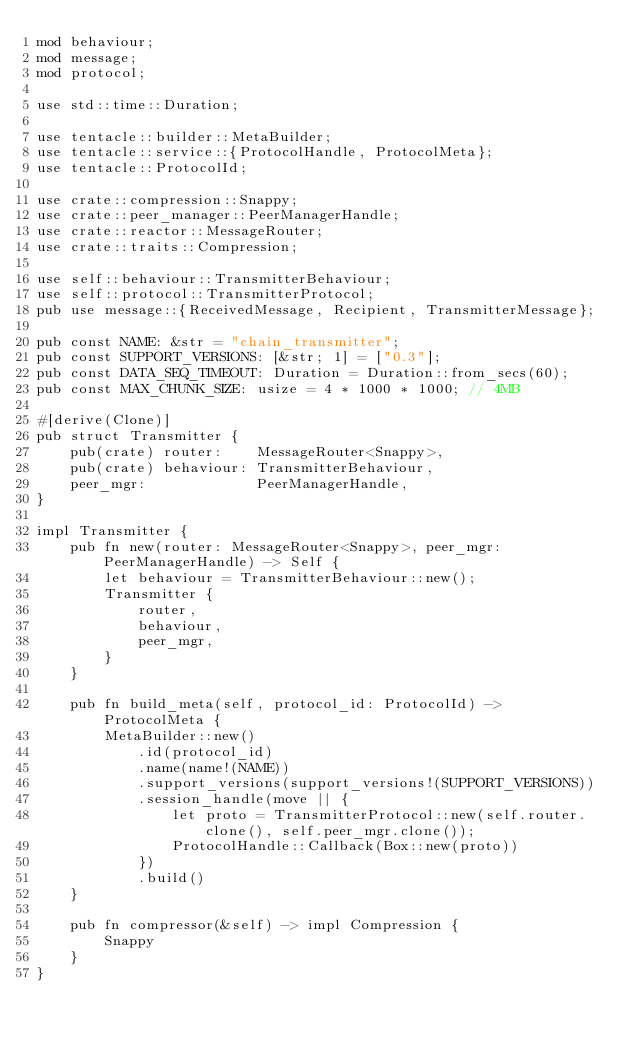<code> <loc_0><loc_0><loc_500><loc_500><_Rust_>mod behaviour;
mod message;
mod protocol;

use std::time::Duration;

use tentacle::builder::MetaBuilder;
use tentacle::service::{ProtocolHandle, ProtocolMeta};
use tentacle::ProtocolId;

use crate::compression::Snappy;
use crate::peer_manager::PeerManagerHandle;
use crate::reactor::MessageRouter;
use crate::traits::Compression;

use self::behaviour::TransmitterBehaviour;
use self::protocol::TransmitterProtocol;
pub use message::{ReceivedMessage, Recipient, TransmitterMessage};

pub const NAME: &str = "chain_transmitter";
pub const SUPPORT_VERSIONS: [&str; 1] = ["0.3"];
pub const DATA_SEQ_TIMEOUT: Duration = Duration::from_secs(60);
pub const MAX_CHUNK_SIZE: usize = 4 * 1000 * 1000; // 4MB

#[derive(Clone)]
pub struct Transmitter {
    pub(crate) router:    MessageRouter<Snappy>,
    pub(crate) behaviour: TransmitterBehaviour,
    peer_mgr:             PeerManagerHandle,
}

impl Transmitter {
    pub fn new(router: MessageRouter<Snappy>, peer_mgr: PeerManagerHandle) -> Self {
        let behaviour = TransmitterBehaviour::new();
        Transmitter {
            router,
            behaviour,
            peer_mgr,
        }
    }

    pub fn build_meta(self, protocol_id: ProtocolId) -> ProtocolMeta {
        MetaBuilder::new()
            .id(protocol_id)
            .name(name!(NAME))
            .support_versions(support_versions!(SUPPORT_VERSIONS))
            .session_handle(move || {
                let proto = TransmitterProtocol::new(self.router.clone(), self.peer_mgr.clone());
                ProtocolHandle::Callback(Box::new(proto))
            })
            .build()
    }

    pub fn compressor(&self) -> impl Compression {
        Snappy
    }
}
</code> 